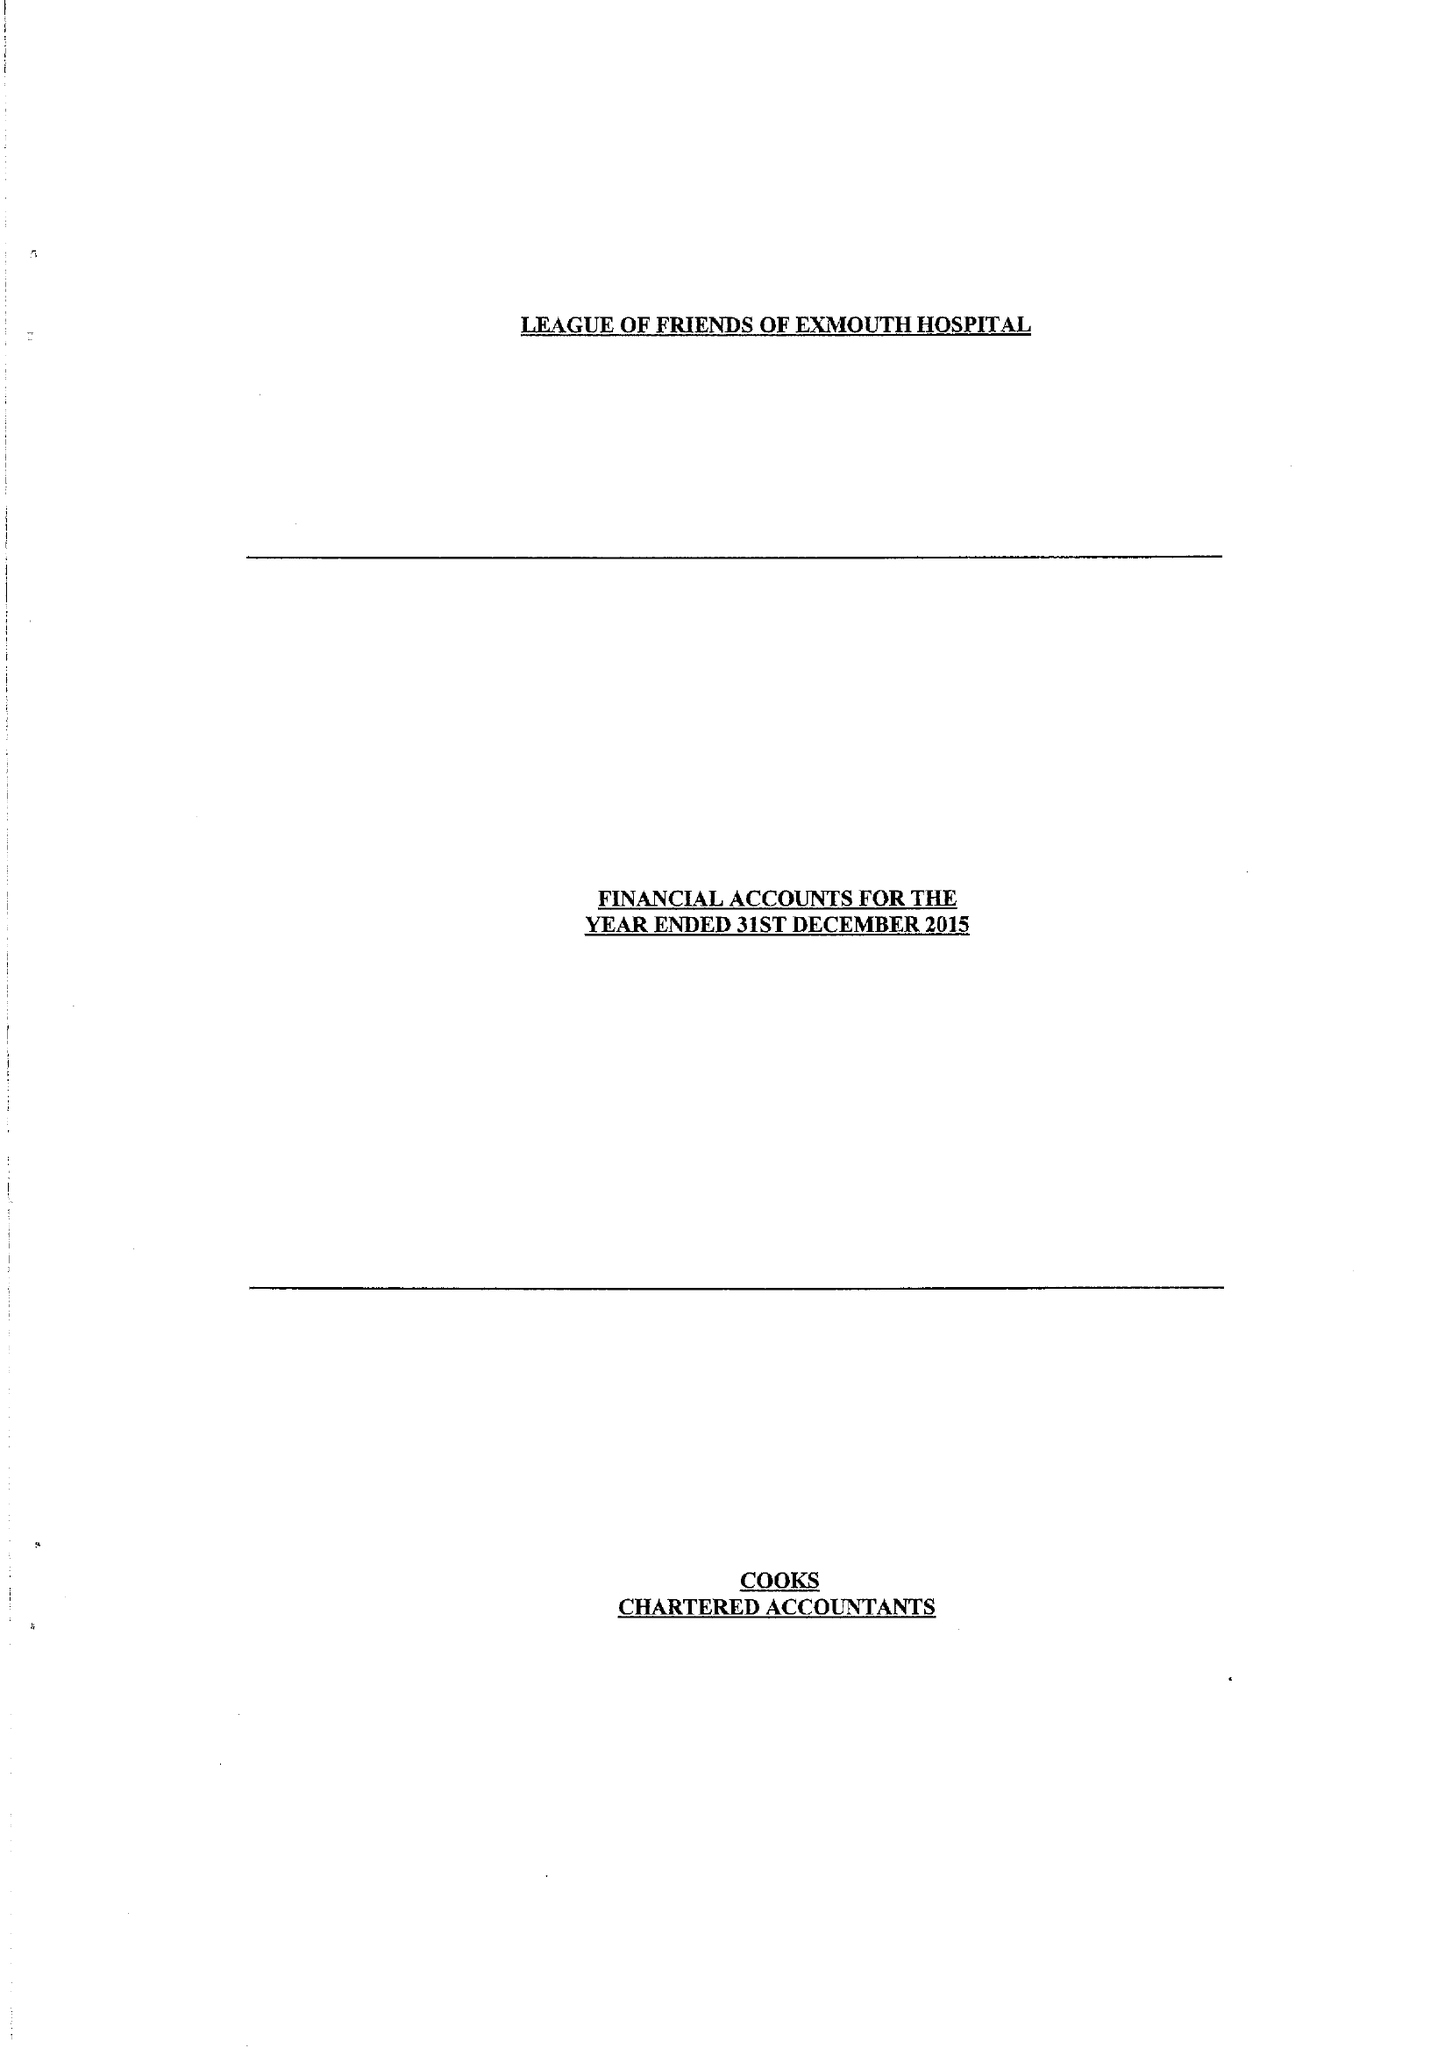What is the value for the report_date?
Answer the question using a single word or phrase. 2015-12-31 